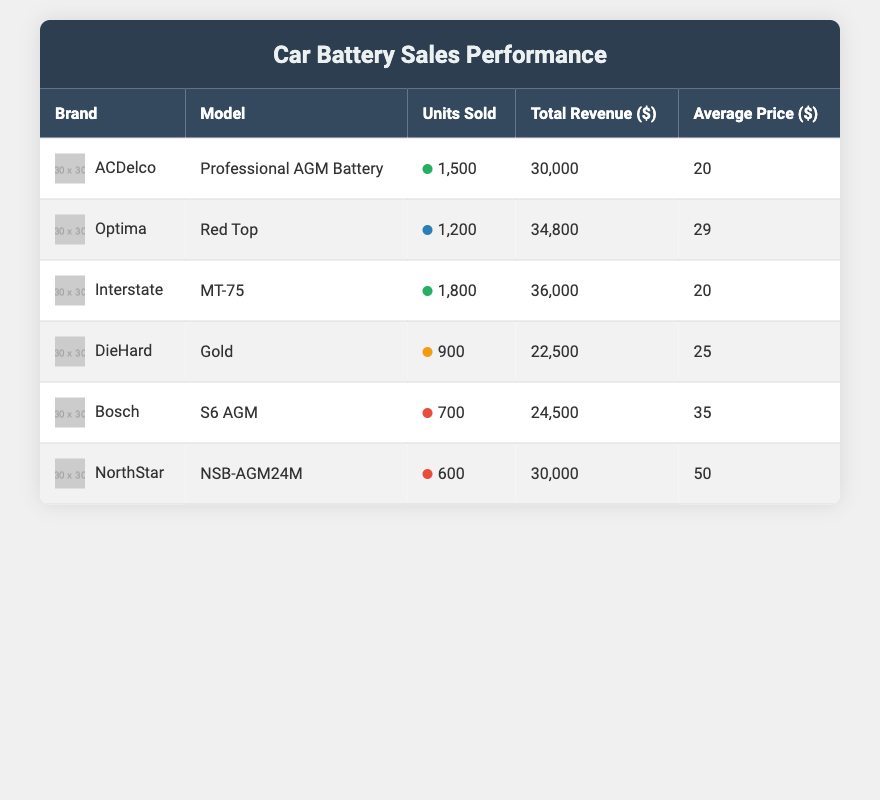What brand had the highest total revenue from car battery sales? Looking at the total revenue column, Interstate with a total revenue of 36,000 has the highest amount, followed by Optima with 34,800.
Answer: Interstate How many units of Bosch brand batteries were sold? The table shows that Bosch sold 700 units.
Answer: 700 What is the average price of ACDelco batteries? The table indicates that the average price of ACDelco batteries is 20.
Answer: 20 Which battery had the lowest units sold, and what was that number? From the units sold column, NorthStar has the lowest number at 600.
Answer: 600 Calculate the total units sold for the top three selling battery brands. The top three selling brands by units sold are Interstate (1800), ACDelco (1500), and Optima (1200). Adding these together: 1800 + 1500 + 1200 = 4500.
Answer: 4500 Is it true that all batteries sold had an average price above 20? Checking the average prices, Bosch (35) and NorthStar (50) are above 20, but ACDelco (20) and Interstate (20) are exactly 20, making the statement false.
Answer: No Which brand has the highest average price and what is that price? The average price of NorthStar is the highest at 50, when comparing all average prices listed in the table.
Answer: 50 If you combine the total revenue of DieHard and Bosch, what would that be? The total revenue for DieHard is 22,500 and for Bosch it is 24,500. Adding these together, 22,500 + 24,500 = 47,000.
Answer: 47000 Which brand sold more units, ACDelco or Optima? Comparing the units sold, ACDelco sold 1500 units while Optima sold 1200 units, showing that ACDelco sold more.
Answer: ACDelco 